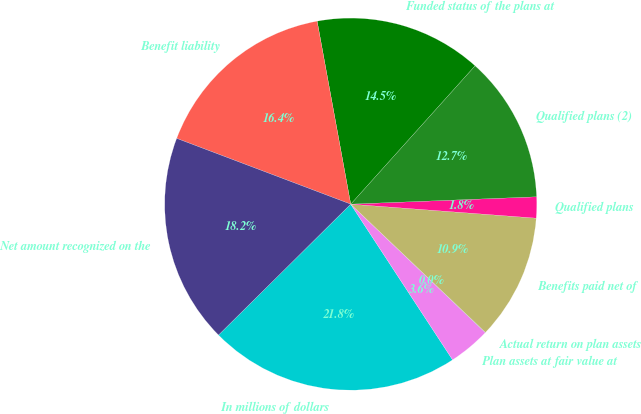Convert chart. <chart><loc_0><loc_0><loc_500><loc_500><pie_chart><fcel>In millions of dollars<fcel>Plan assets at fair value at<fcel>Actual return on plan assets<fcel>Benefits paid net of<fcel>Qualified plans<fcel>Qualified plans (2)<fcel>Funded status of the plans at<fcel>Benefit liability<fcel>Net amount recognized on the<nl><fcel>21.8%<fcel>3.65%<fcel>0.02%<fcel>10.91%<fcel>1.83%<fcel>12.72%<fcel>14.54%<fcel>16.36%<fcel>18.17%<nl></chart> 